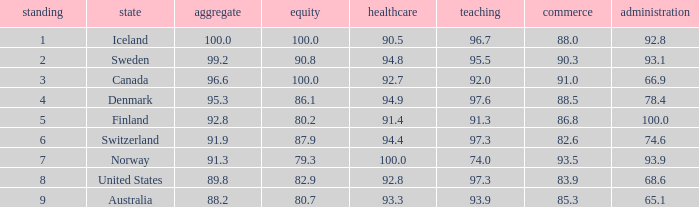What's the country with health being 91.4 Finland. 